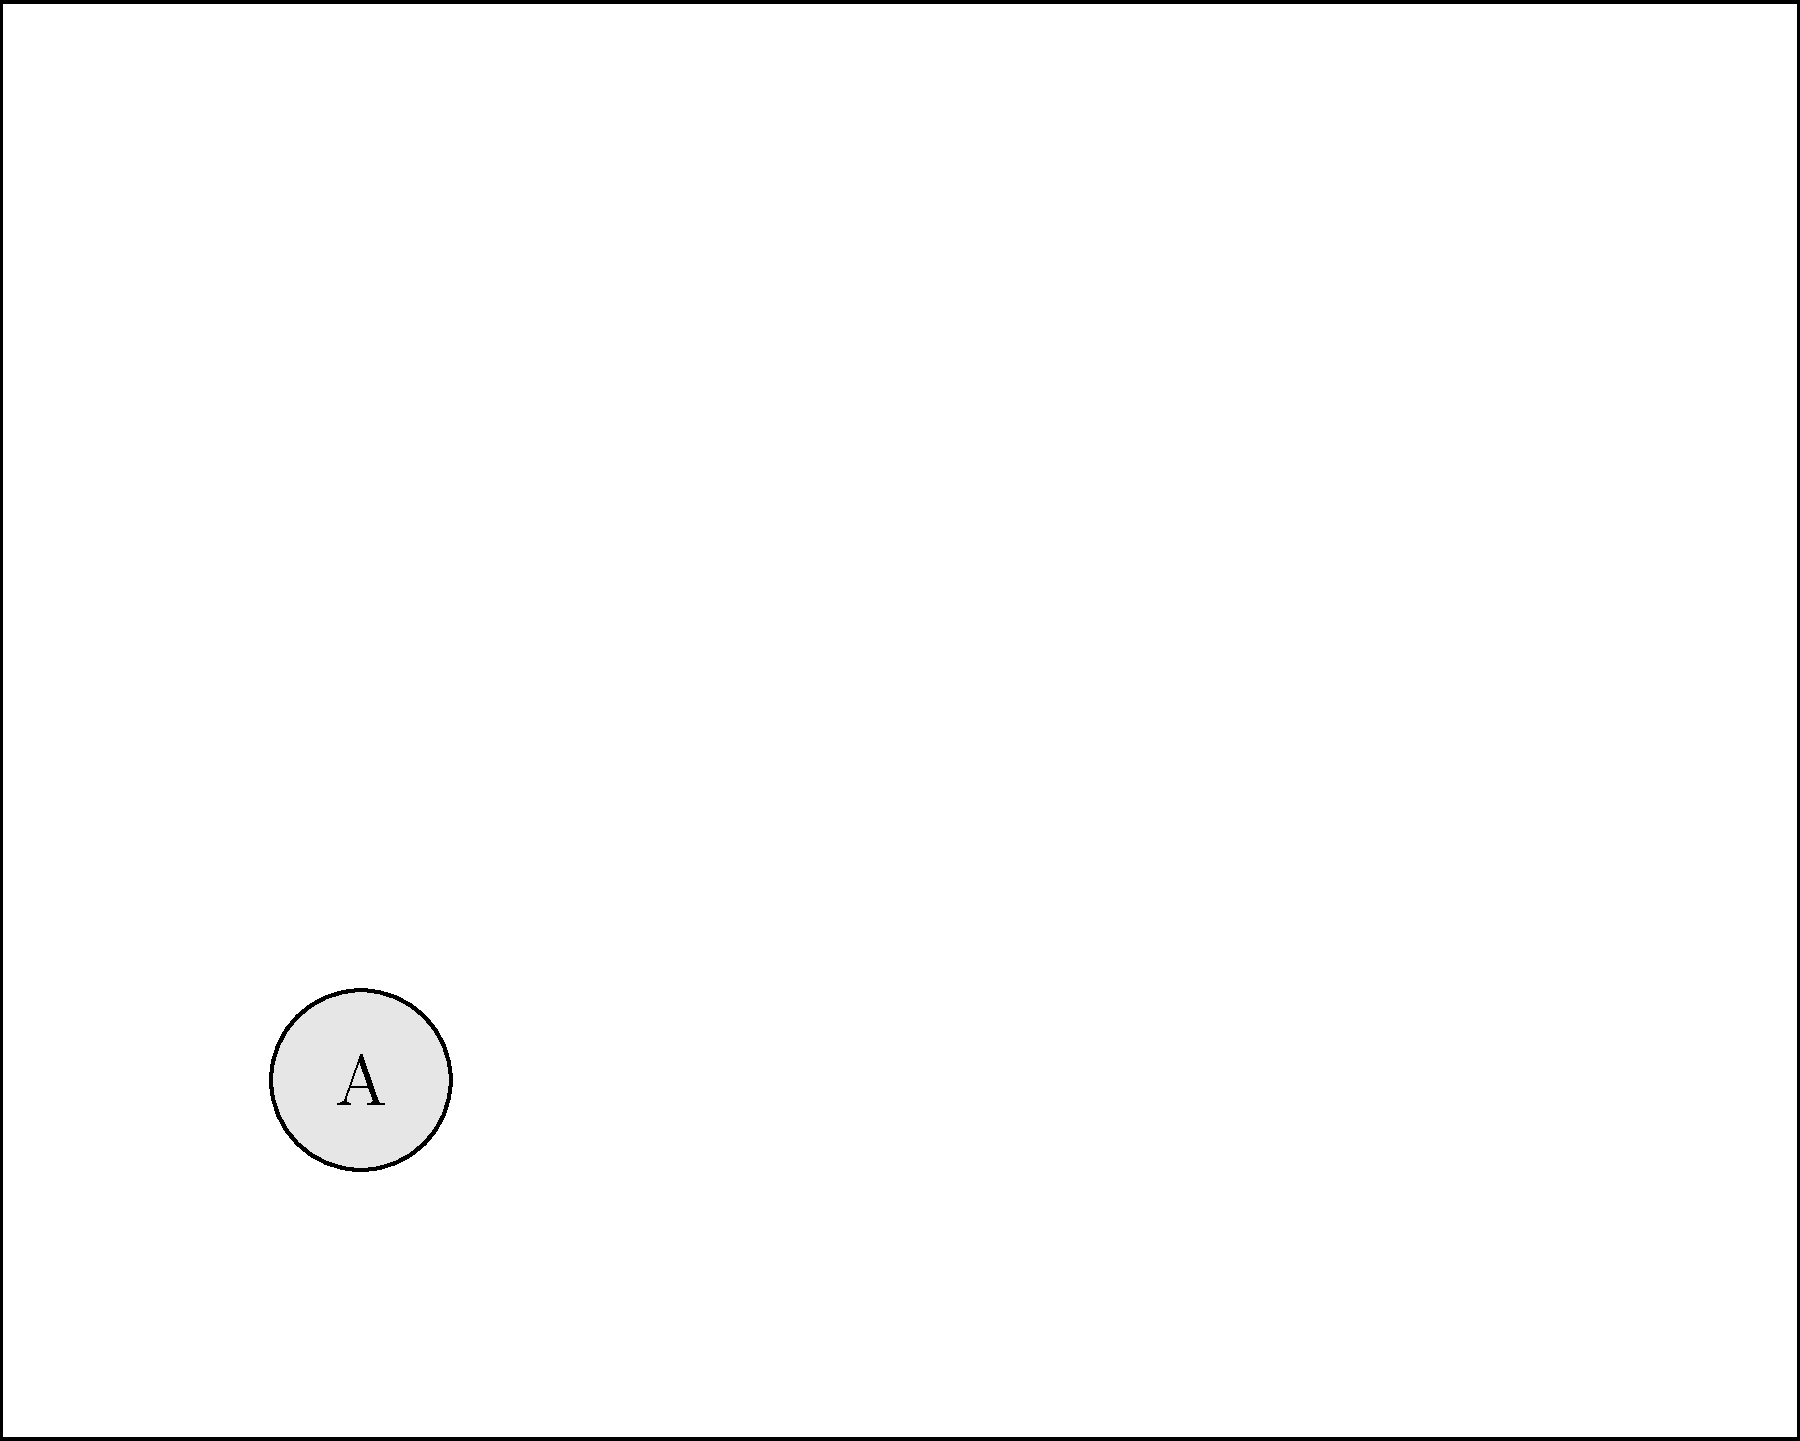Based on the ICU room layout shown, which piece of equipment is crucial for assisting patients with breathing difficulties and is typically located near the head of the bed? To answer this question, let's analyze the ICU room layout step-by-step:

1. We can see four main pieces of equipment labeled A, B, C, and D.

2. The legend provides information about each piece of equipment:
   A: Ventilator
   B: Patient bed
   C: Monitoring equipment
   D: IV stand

3. The question asks about equipment that assists patients with breathing difficulties.

4. Among the listed equipment, only the ventilator (A) is specifically designed to help patients breathe.

5. The ventilator (A) is located near the head of the patient bed (B), which is the typical positioning for easy access and efficient use.

6. Other equipment, such as the monitoring equipment (C) and IV stand (D), while important, are not primarily used for assisting with breathing.

Therefore, the piece of equipment crucial for assisting patients with breathing difficulties and typically located near the head of the bed is the ventilator (A).
Answer: Ventilator 